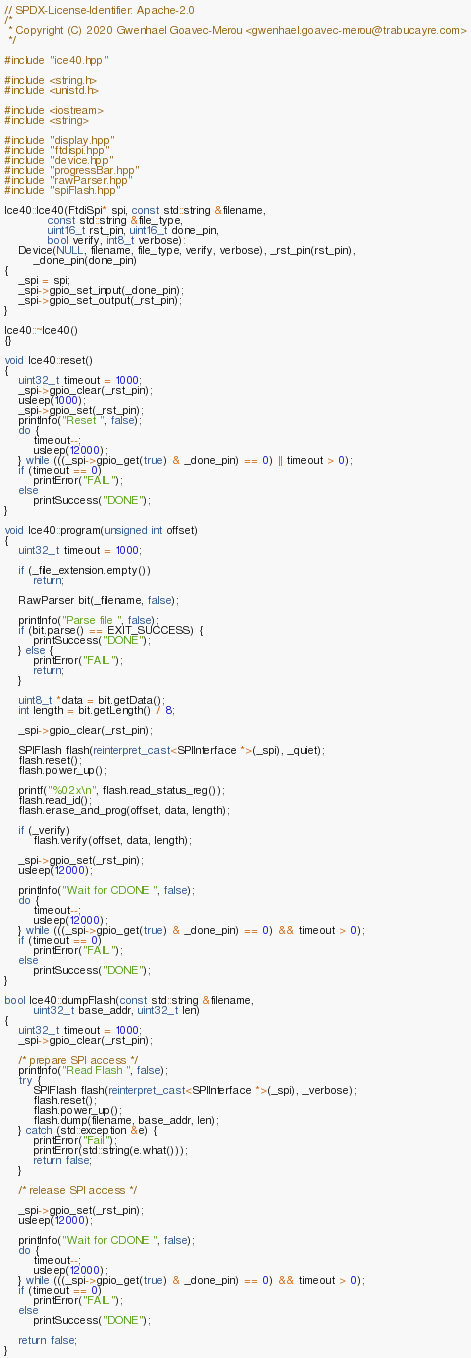<code> <loc_0><loc_0><loc_500><loc_500><_C++_>// SPDX-License-Identifier: Apache-2.0
/*
 * Copyright (C) 2020 Gwenhael Goavec-Merou <gwenhael.goavec-merou@trabucayre.com>
 */

#include "ice40.hpp"

#include <string.h>
#include <unistd.h>

#include <iostream>
#include <string>

#include "display.hpp"
#include "ftdispi.hpp"
#include "device.hpp"
#include "progressBar.hpp"
#include "rawParser.hpp"
#include "spiFlash.hpp"

Ice40::Ice40(FtdiSpi* spi, const std::string &filename,
			const std::string &file_type,
			uint16_t rst_pin, uint16_t done_pin,
			bool verify, int8_t verbose):
	Device(NULL, filename, file_type, verify, verbose), _rst_pin(rst_pin),
		_done_pin(done_pin)
{
	_spi = spi;
	_spi->gpio_set_input(_done_pin);
	_spi->gpio_set_output(_rst_pin);
}

Ice40::~Ice40()
{}

void Ice40::reset()
{
	uint32_t timeout = 1000;
	_spi->gpio_clear(_rst_pin);
	usleep(1000);
	_spi->gpio_set(_rst_pin);
	printInfo("Reset ", false);
	do {
		timeout--;
		usleep(12000);
	} while (((_spi->gpio_get(true) & _done_pin) == 0) || timeout > 0);
	if (timeout == 0)
		printError("FAIL");
	else
		printSuccess("DONE");
}

void Ice40::program(unsigned int offset)
{
	uint32_t timeout = 1000;

	if (_file_extension.empty())
		return;

	RawParser bit(_filename, false);

	printInfo("Parse file ", false);
	if (bit.parse() == EXIT_SUCCESS) {
		printSuccess("DONE");
	} else {
		printError("FAIL");
		return;
	}

	uint8_t *data = bit.getData();
	int length = bit.getLength() / 8;

	_spi->gpio_clear(_rst_pin);

	SPIFlash flash(reinterpret_cast<SPIInterface *>(_spi), _quiet);
	flash.reset();
	flash.power_up();

	printf("%02x\n", flash.read_status_reg());
	flash.read_id();
	flash.erase_and_prog(offset, data, length);

	if (_verify)
		flash.verify(offset, data, length);

	_spi->gpio_set(_rst_pin);
	usleep(12000);

	printInfo("Wait for CDONE ", false);
	do {
		timeout--;
		usleep(12000);
	} while (((_spi->gpio_get(true) & _done_pin) == 0) && timeout > 0);
	if (timeout == 0)
		printError("FAIL");
	else
		printSuccess("DONE");
}

bool Ice40::dumpFlash(const std::string &filename,
		uint32_t base_addr, uint32_t len)
{
	uint32_t timeout = 1000;
	_spi->gpio_clear(_rst_pin);

	/* prepare SPI access */
	printInfo("Read Flash ", false);
	try {
		SPIFlash flash(reinterpret_cast<SPIInterface *>(_spi), _verbose);
		flash.reset();
		flash.power_up();
		flash.dump(filename, base_addr, len);
	} catch (std::exception &e) {
		printError("Fail");
		printError(std::string(e.what()));
		return false;
	}

	/* release SPI access */

	_spi->gpio_set(_rst_pin);
	usleep(12000);

	printInfo("Wait for CDONE ", false);
	do {
		timeout--;
		usleep(12000);
	} while (((_spi->gpio_get(true) & _done_pin) == 0) && timeout > 0);
	if (timeout == 0)
		printError("FAIL");
	else
		printSuccess("DONE");

	return false;
}
</code> 